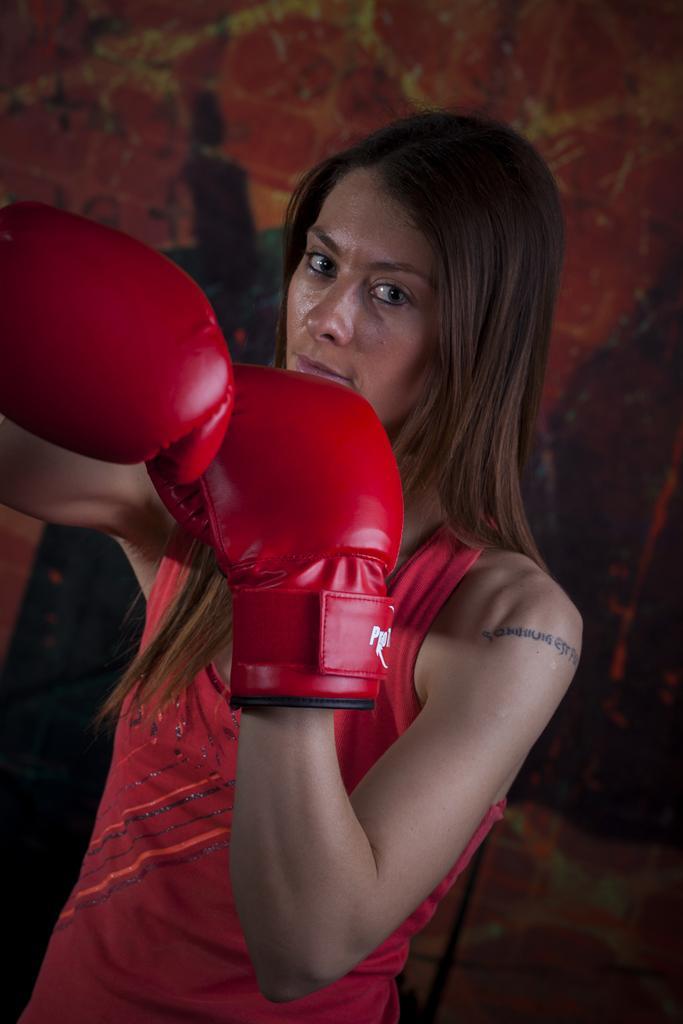In one or two sentences, can you explain what this image depicts? In the image there is a woman, she is wearing red boxing gloves to her hand and the background of the woman is blur. 